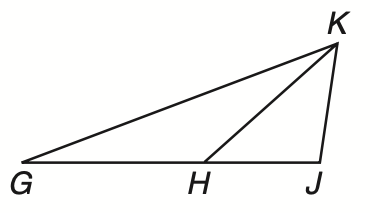Answer the mathemtical geometry problem and directly provide the correct option letter.
Question: If G H \cong H K, H J \cong Y K, and m \angle G J K = 100, what is the measure of \angle H G K?
Choices: A: 10 B: 15 C: 20 D: 25 C 